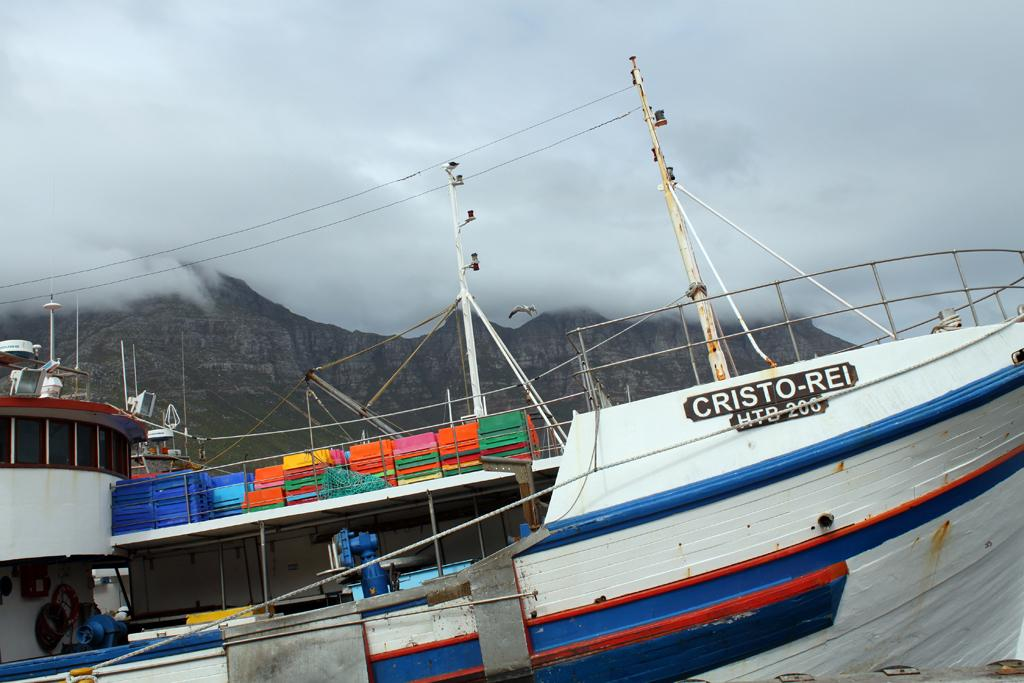What is the main subject of the image? The main subject of the image is a ship. What specific features can be seen on the ship? Poles, ropes, and a fence are visible on the ship. Are there any other objects on the ship that are not specified? Yes, there are other unspecified objects on the ship. What can be seen in the background of the image? There is a mountain, smoke, and the sky visible in the background of the image. What type of voice can be heard coming from the vase on the ship? There is no vase present on the ship, and therefore no voice can be heard coming from it. What shape is the square object on the ship? There is no square object present on the ship. 